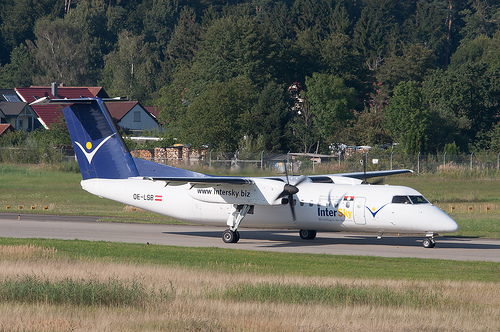Imagine this airplane is part of a movie scene. What could be the story around this setting? In a thrilling action movie, this serene airport becomes the pivotal setting for a high-stakes chase. Our protagonist, a daring secret agent, has just uncovered a plot that could threaten national security. Chased by the antagonists through the forest, he sprints towards the airplane, the only means of escape. The lush green foliage offers temporary cover, but the agent knows time is of the essence. With the enemies closing in, he reaches the runway and the airplane's door opens. The engines start to roar as he jumps inside, and the plane begins to taxi down the runway. Bullets ricochet off the plane's body while it accelerates towards takeoff. Just as the forest line nears and the antagonists close the distance, the airplane lifts off, ascending over the trees, the secret information safe onboard. 